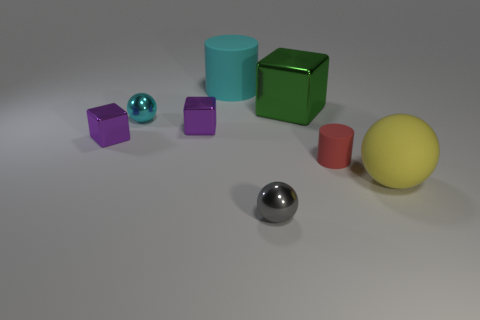Is the material of the tiny ball behind the big ball the same as the red object?
Provide a succinct answer. No. What color is the other small sphere that is the same material as the small cyan ball?
Make the answer very short. Gray. Is the number of tiny red rubber objects that are on the right side of the large green cube less than the number of objects behind the big cylinder?
Ensure brevity in your answer.  No. There is a small object in front of the large yellow object; is its color the same as the matte object behind the green cube?
Your response must be concise. No. Are there any purple cubes that have the same material as the big yellow ball?
Your response must be concise. No. There is a metal block right of the big rubber thing that is behind the red matte cylinder; what is its size?
Your answer should be compact. Large. Are there more large green metallic cubes than small gray shiny cubes?
Your answer should be very brief. Yes. Do the cube that is behind the cyan ball and the tiny red matte cylinder have the same size?
Your answer should be compact. No. What number of balls are the same color as the large matte cylinder?
Offer a terse response. 1. Do the big yellow matte object and the tiny gray thing have the same shape?
Offer a terse response. Yes. 